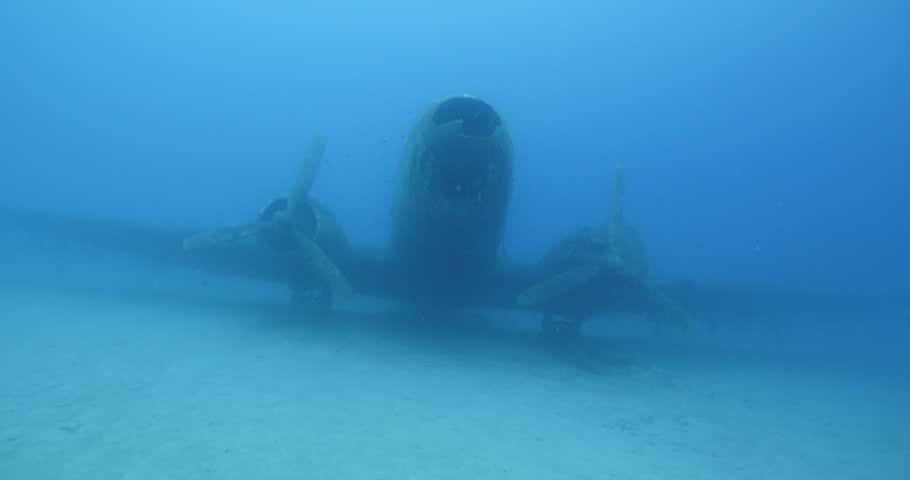How many unicorns would there be in the image now that three more unicorns have been moved into the scene? If we were to imagine a scenario where it's possible to move three unicorns into the underwater scene depicted, we would then say there are three unicorns in the image, playfully interacting with the airplane wreckage in their new aquatic environment. 